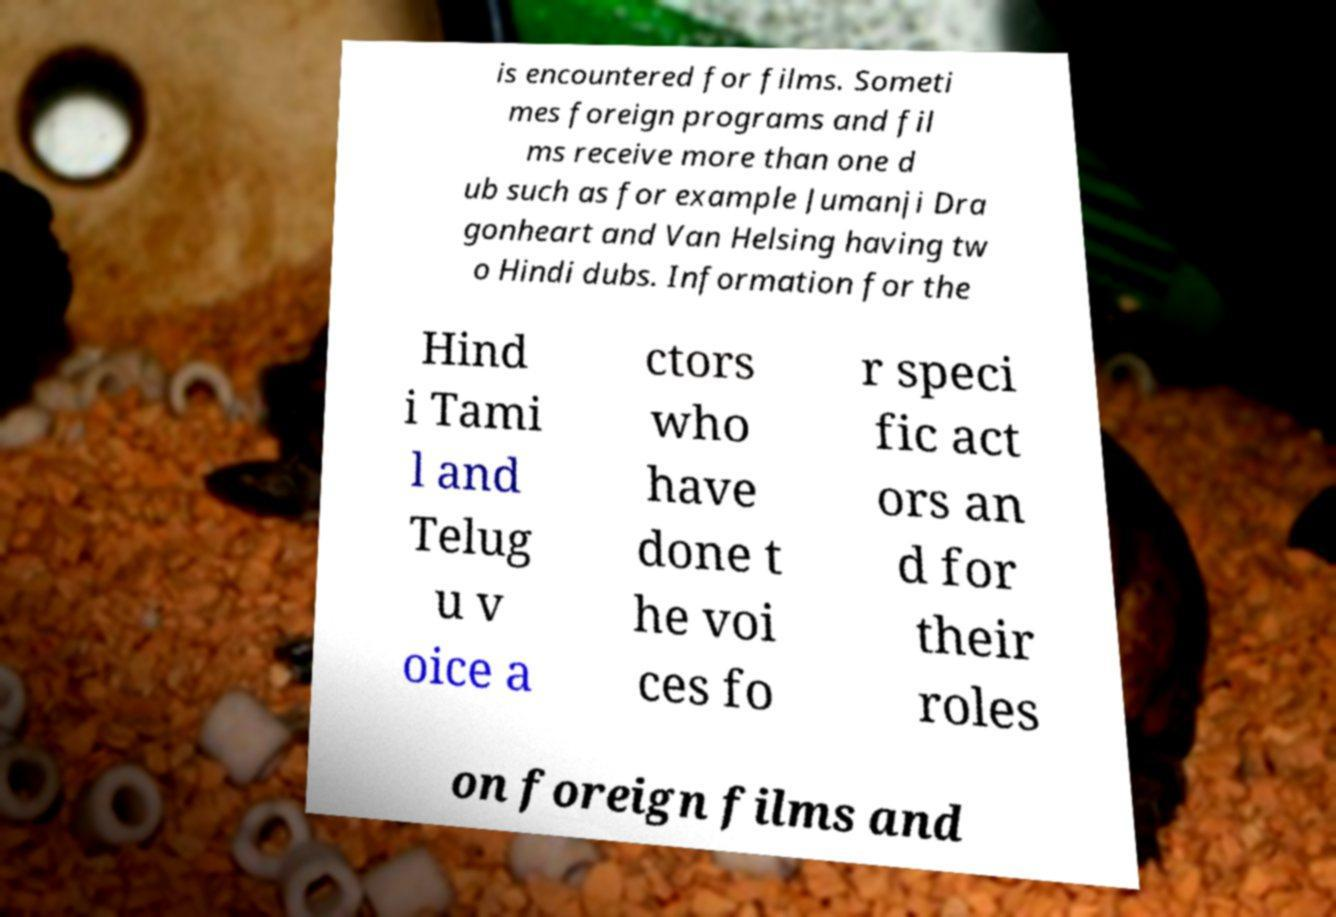Could you extract and type out the text from this image? is encountered for films. Someti mes foreign programs and fil ms receive more than one d ub such as for example Jumanji Dra gonheart and Van Helsing having tw o Hindi dubs. Information for the Hind i Tami l and Telug u v oice a ctors who have done t he voi ces fo r speci fic act ors an d for their roles on foreign films and 